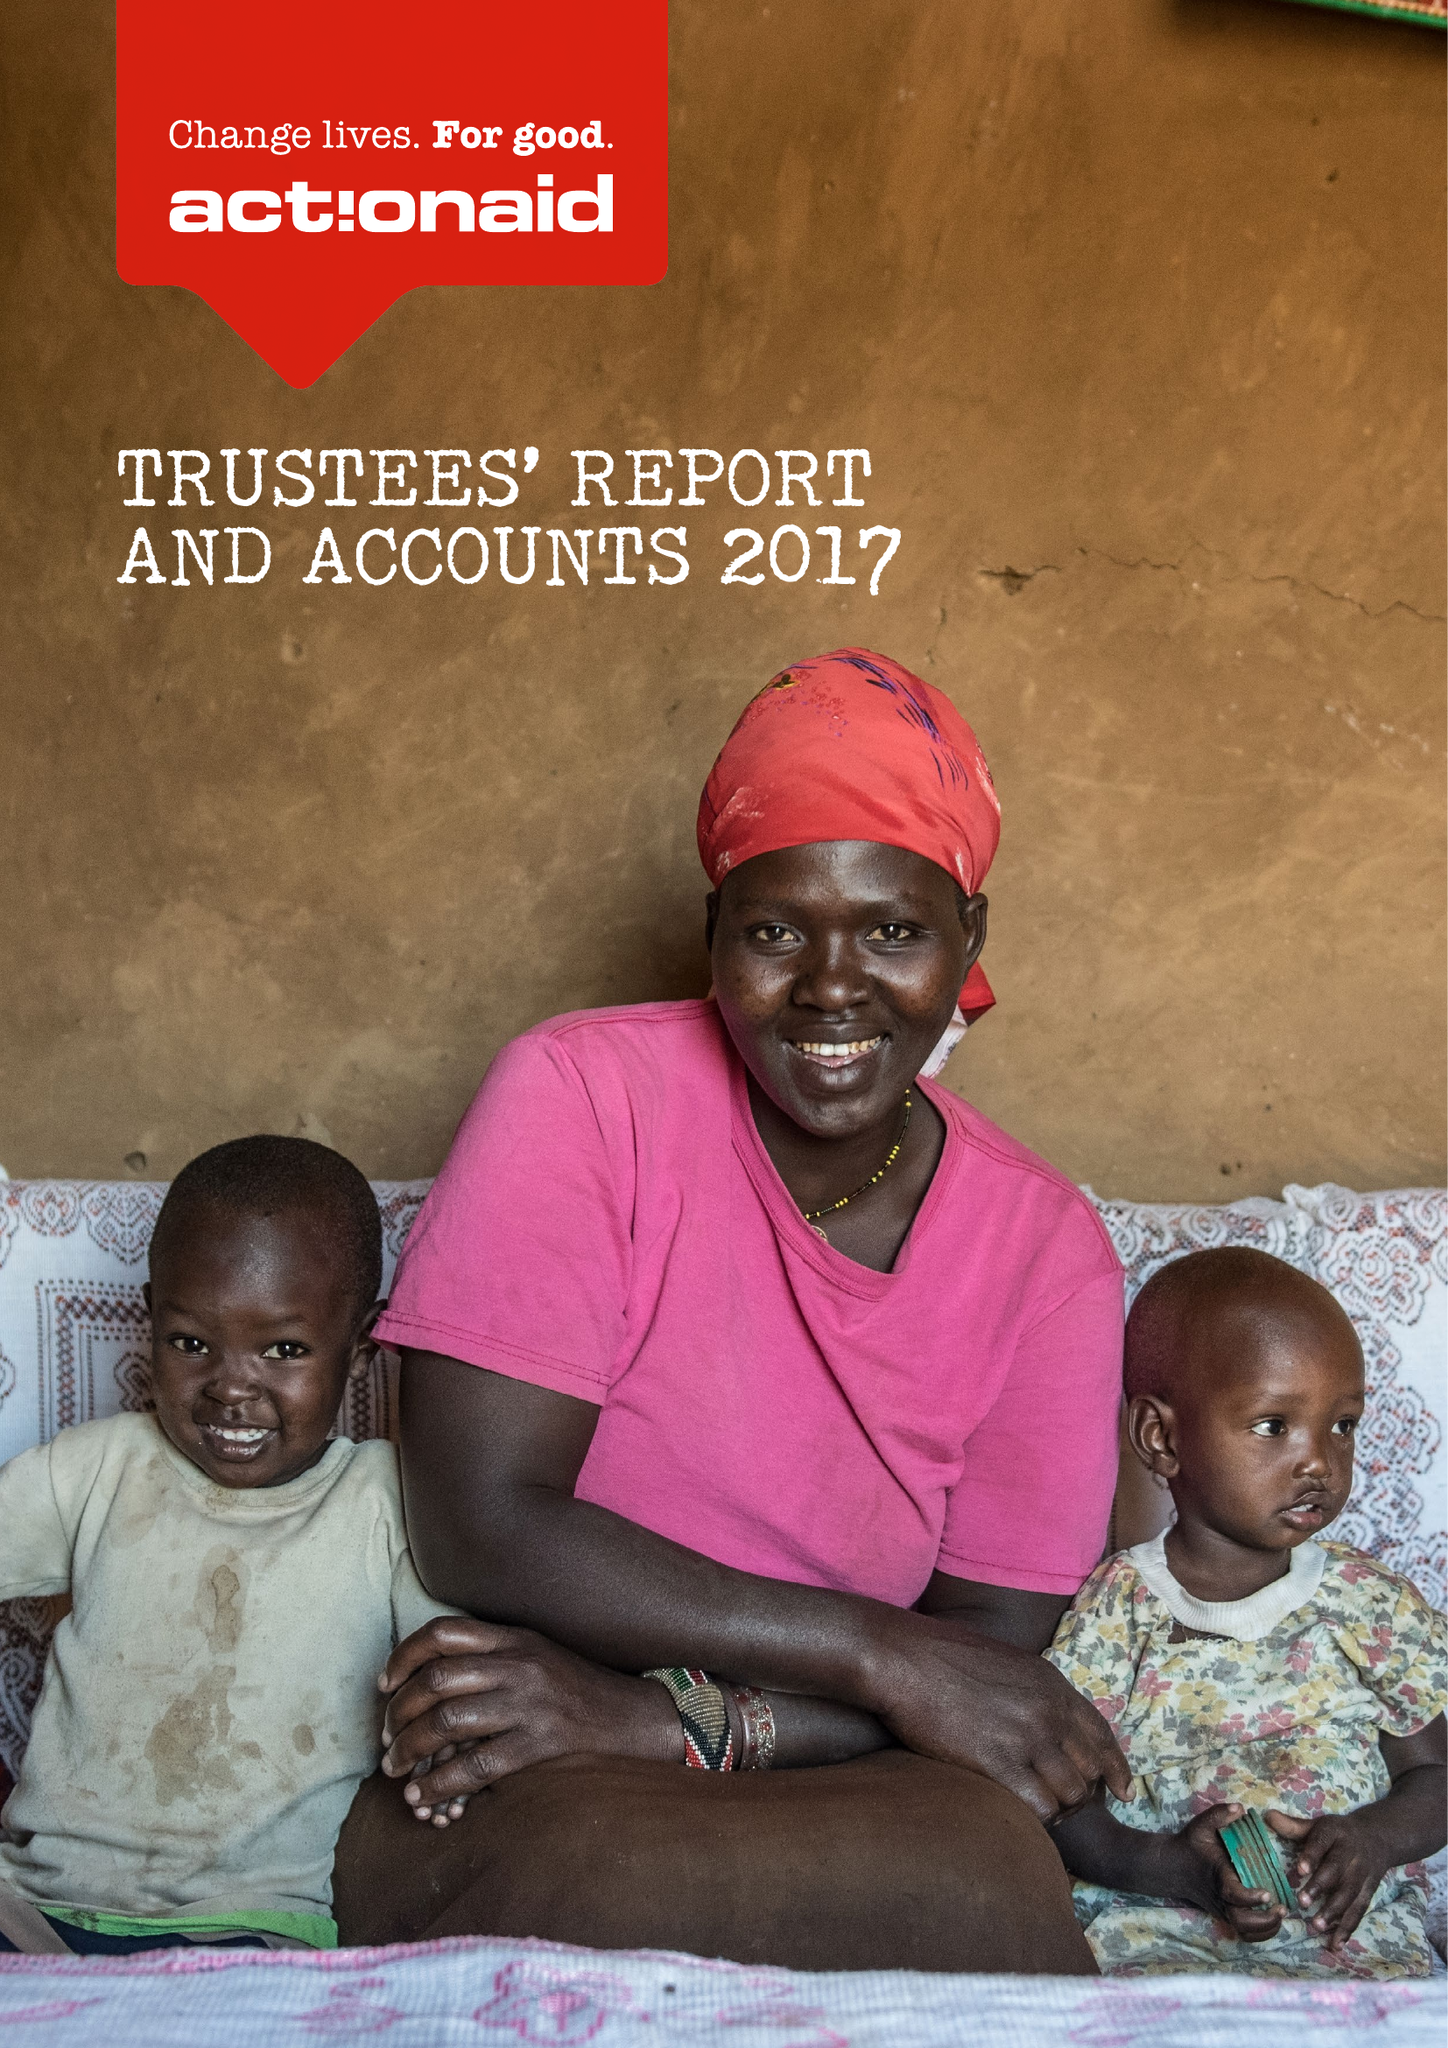What is the value for the address__postcode?
Answer the question using a single word or phrase. EC1R 0BJ 